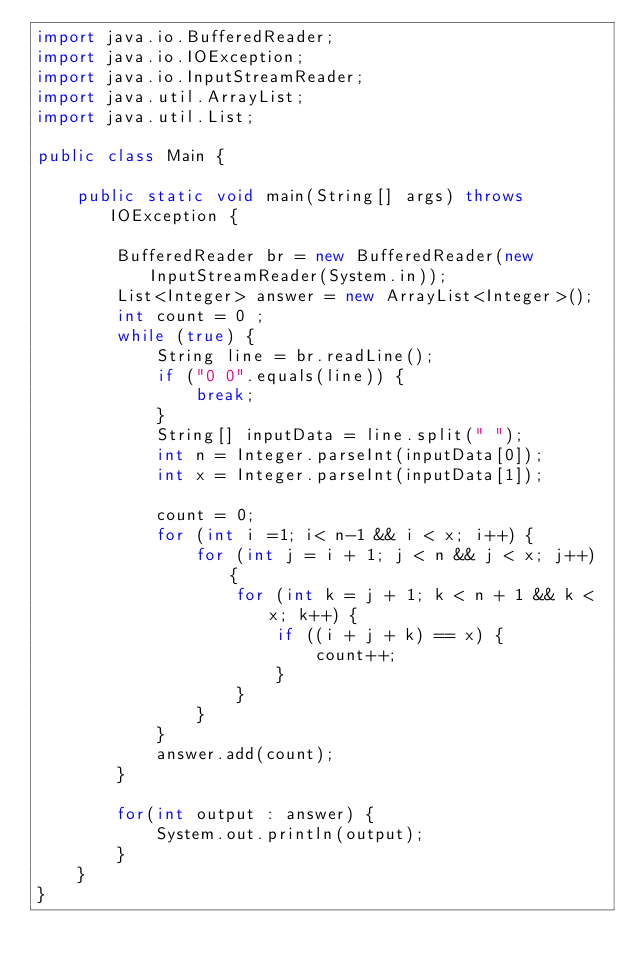<code> <loc_0><loc_0><loc_500><loc_500><_Java_>import java.io.BufferedReader;
import java.io.IOException;
import java.io.InputStreamReader;
import java.util.ArrayList;
import java.util.List;

public class Main {

	public static void main(String[] args) throws IOException {

		BufferedReader br = new BufferedReader(new InputStreamReader(System.in));
		List<Integer> answer = new ArrayList<Integer>();
		int count = 0 ;
		while (true) {
			String line = br.readLine();
			if ("0 0".equals(line)) {
				break;
			}
			String[] inputData = line.split(" ");
			int n = Integer.parseInt(inputData[0]);
			int x = Integer.parseInt(inputData[1]);

			count = 0;
			for (int i =1; i< n-1 && i < x; i++) {
				for (int j = i + 1; j < n && j < x; j++) {
					for (int k = j + 1; k < n + 1 && k < x; k++) {
						if ((i + j + k) == x) {
							count++;
						}
					}
				}
			}
			answer.add(count);
		}

		for(int output : answer) {
			System.out.println(output);
		}
	}
}</code> 